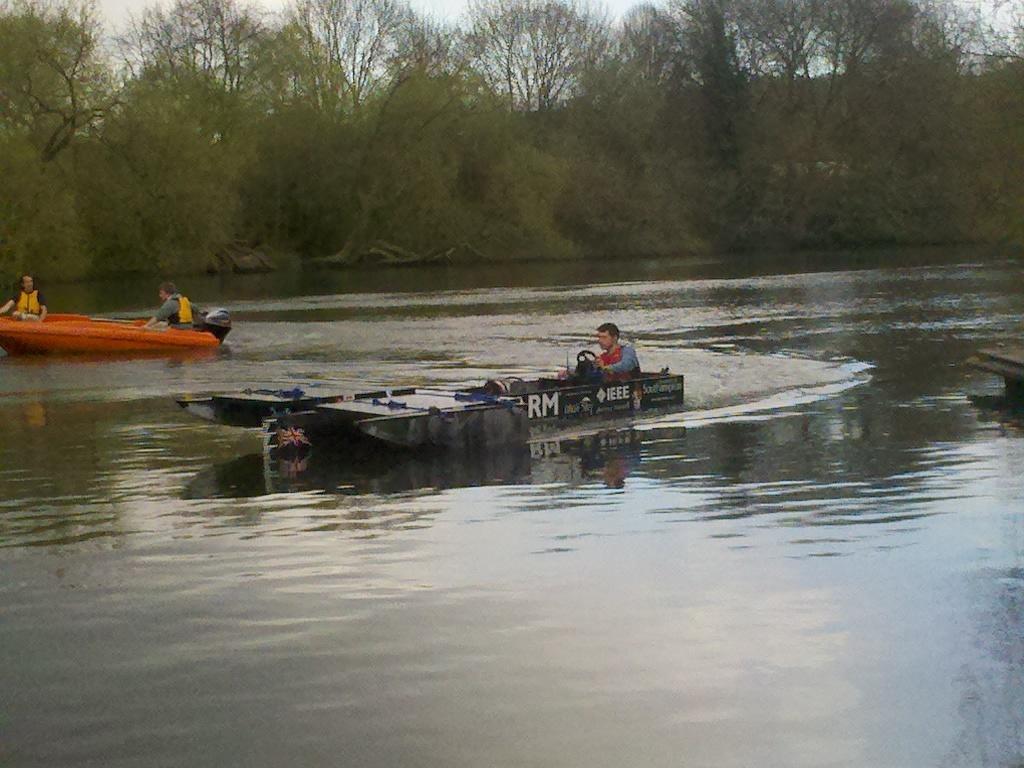In one or two sentences, can you explain what this image depicts? In this image, I can see three persons are boating in the water. In the background, I can see trees and the sky. This image taken, maybe in the lake. 